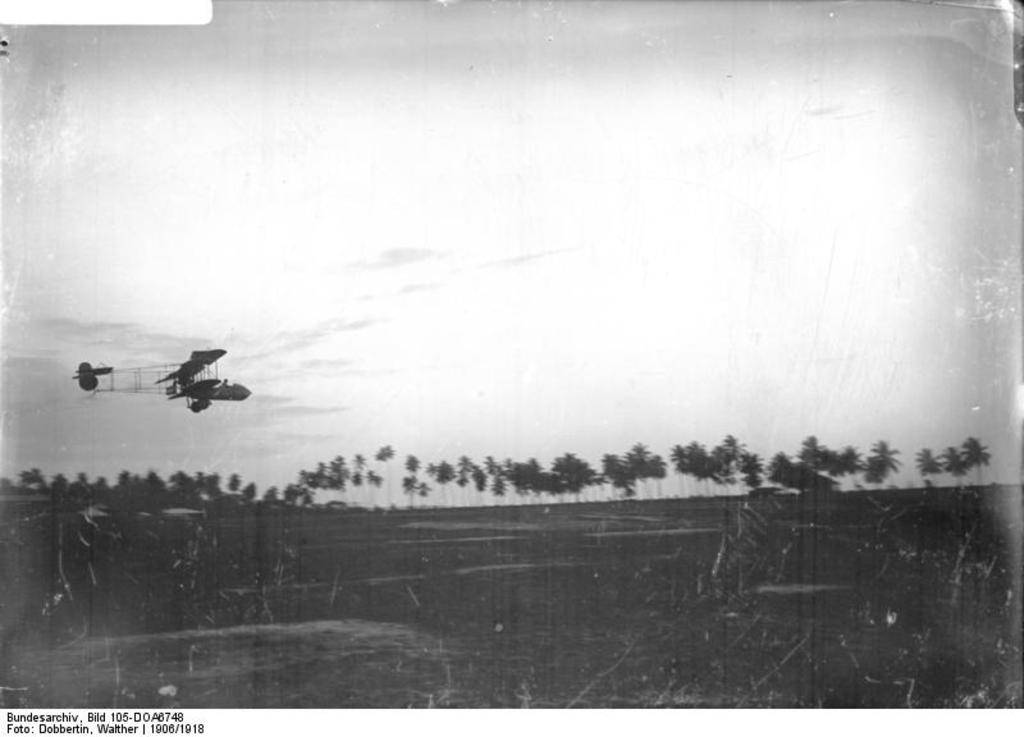What type of vegetation can be seen in the image? There are trees in the image. What part of the natural environment is visible in the image? The sky is visible in the background of the image. What is the color scheme of the image? The image is in black and white. What type of pocket can be seen in the image? There is no pocket present in the image. What is the zinc content of the trees in the image? The image does not provide information about the zinc content of the trees. 